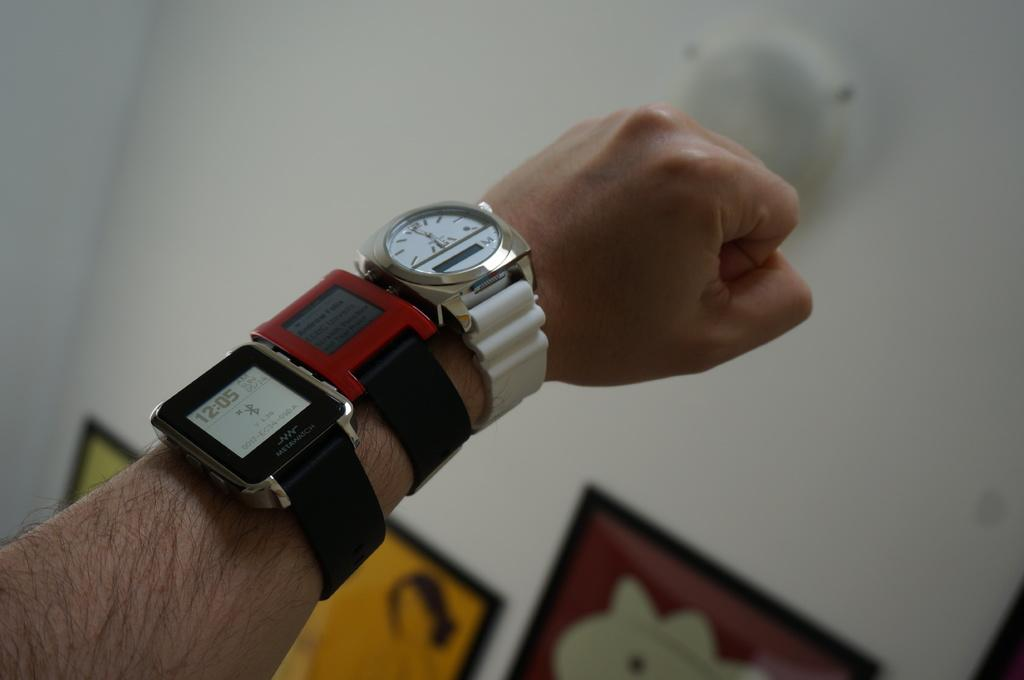<image>
Summarize the visual content of the image. According to the watch on the man's wrist, it is 12:05. 